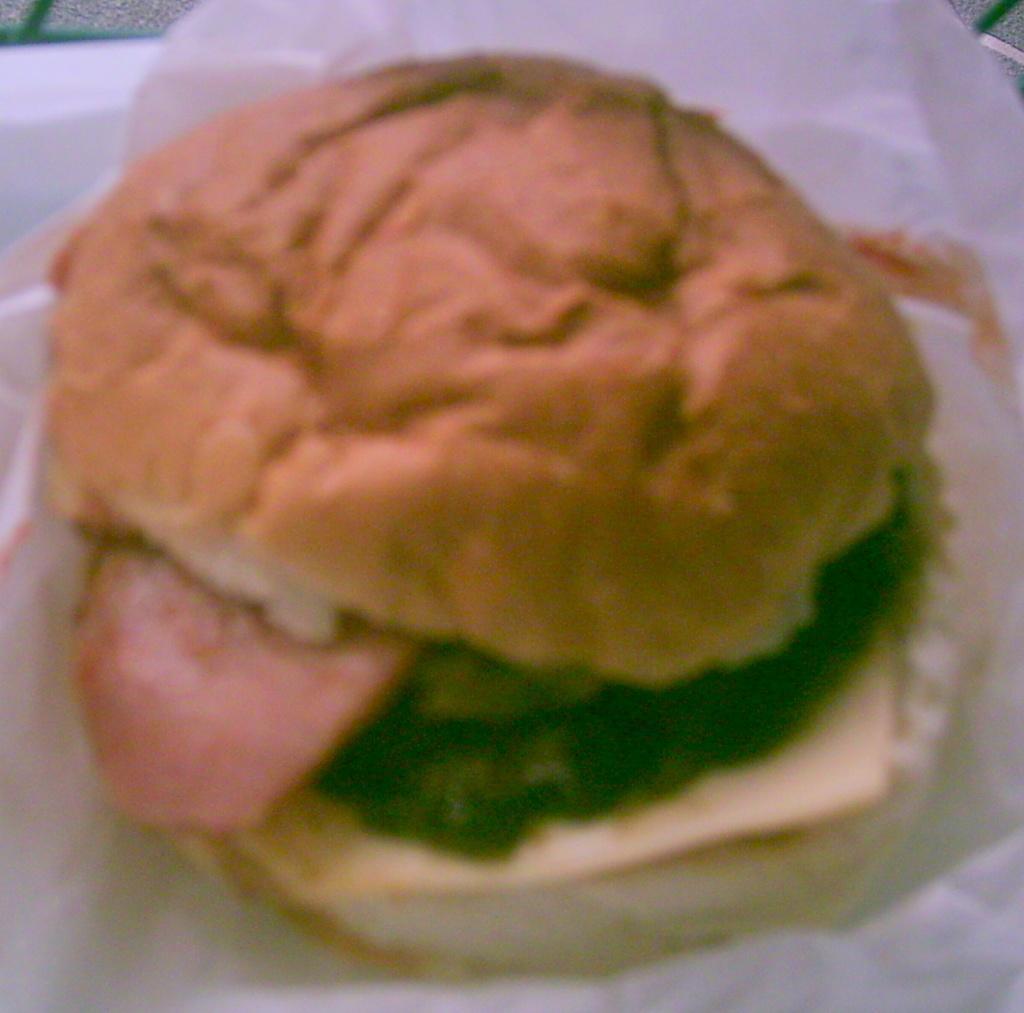In one or two sentences, can you explain what this image depicts? Here I can see a burger which is packed in a white color paper. This is placed in a plate. 